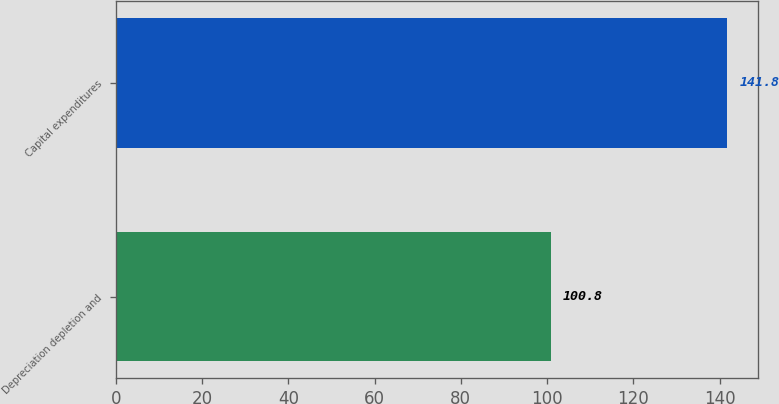<chart> <loc_0><loc_0><loc_500><loc_500><bar_chart><fcel>Depreciation depletion and<fcel>Capital expenditures<nl><fcel>100.8<fcel>141.8<nl></chart> 